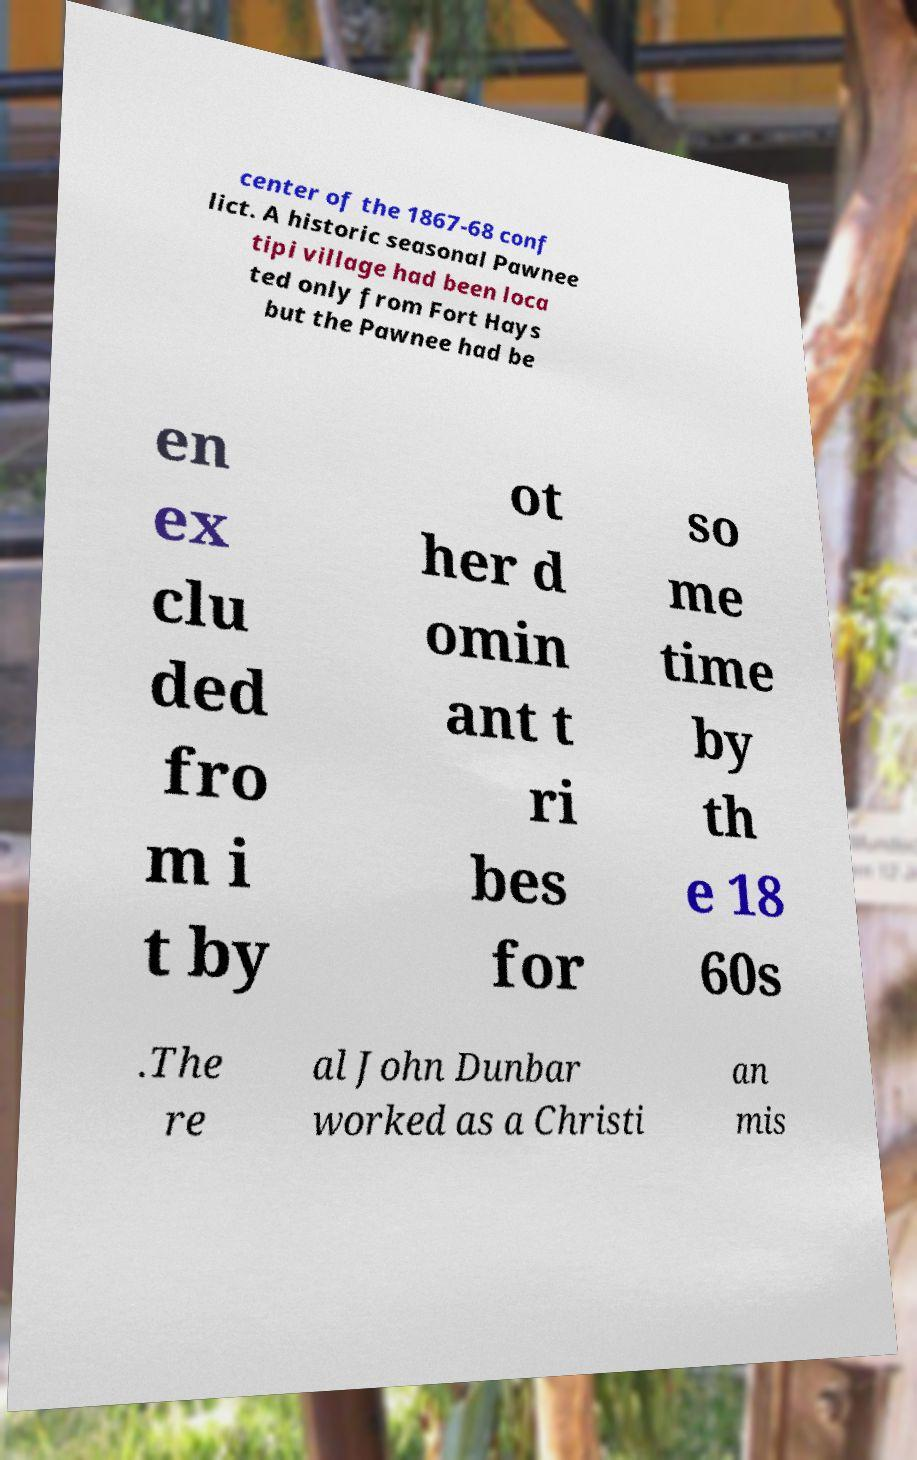I need the written content from this picture converted into text. Can you do that? center of the 1867-68 conf lict. A historic seasonal Pawnee tipi village had been loca ted only from Fort Hays but the Pawnee had be en ex clu ded fro m i t by ot her d omin ant t ri bes for so me time by th e 18 60s .The re al John Dunbar worked as a Christi an mis 